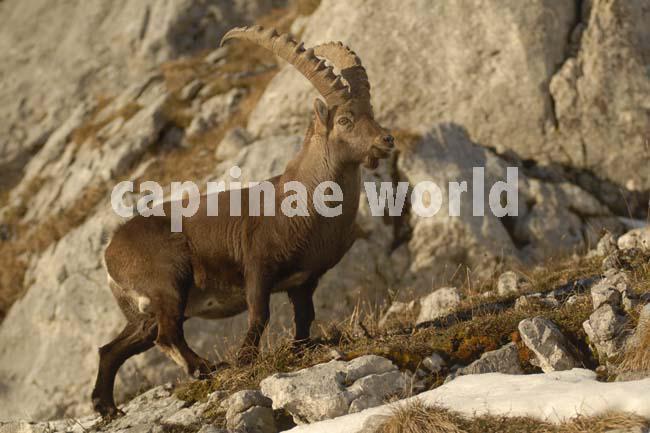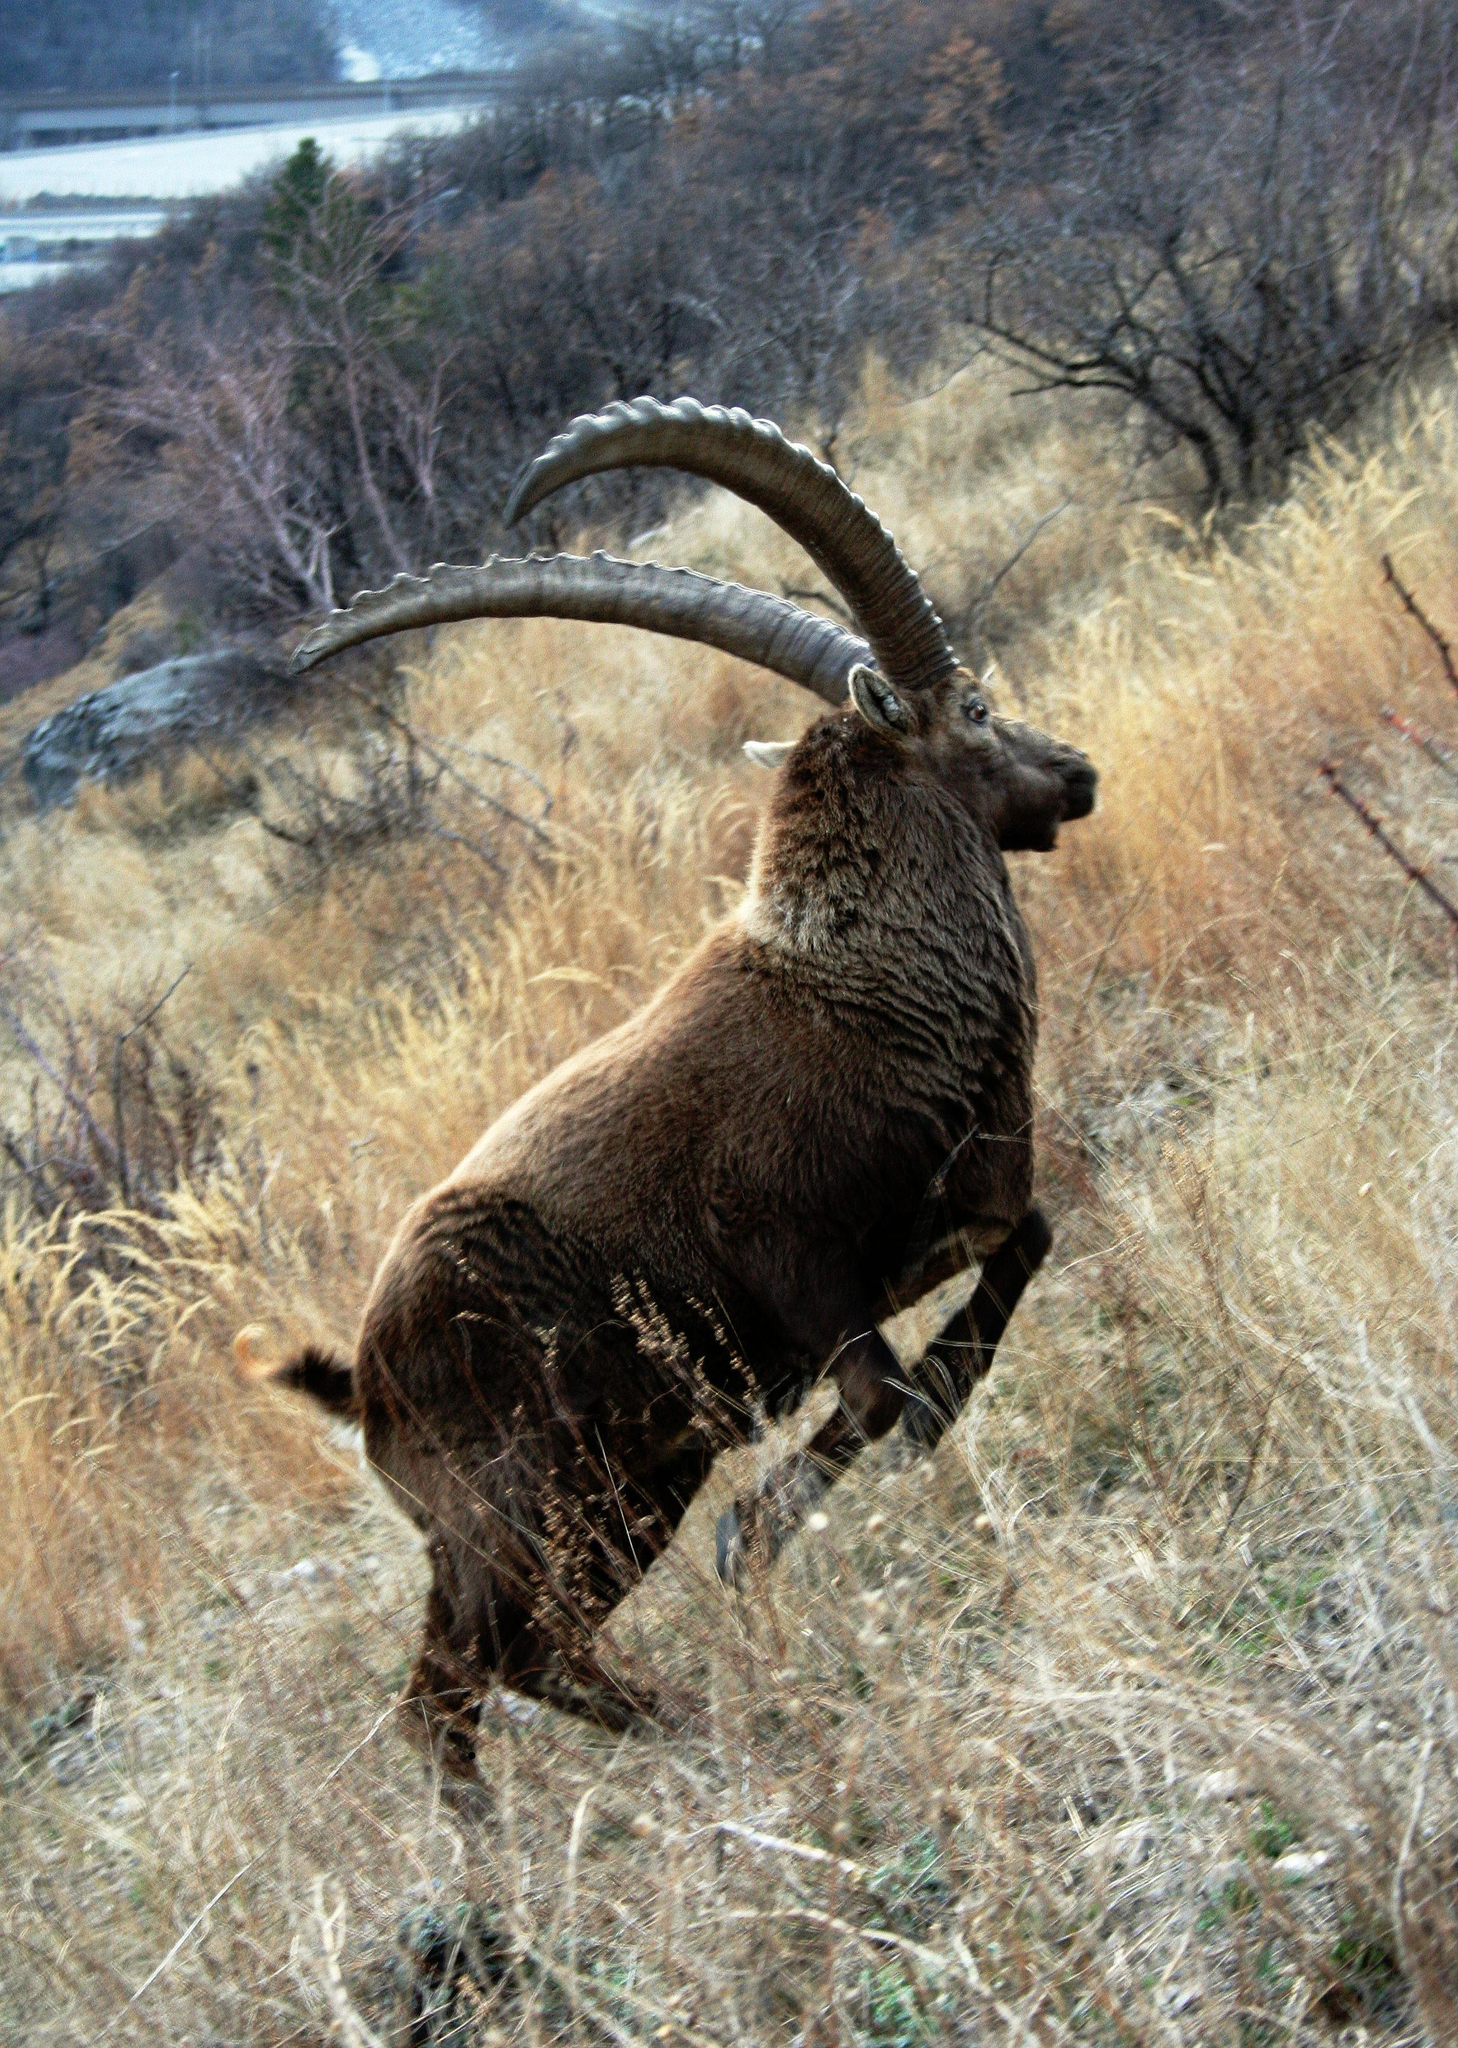The first image is the image on the left, the second image is the image on the right. For the images displayed, is the sentence "The animal in the image on the right is sitting and resting." factually correct? Answer yes or no. No. The first image is the image on the left, the second image is the image on the right. For the images shown, is this caption "A horned animal has both front legs off the ground in one image." true? Answer yes or no. Yes. 